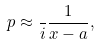Convert formula to latex. <formula><loc_0><loc_0><loc_500><loc_500>p \approx \frac { } { i } \frac { 1 } { x - a } ,</formula> 